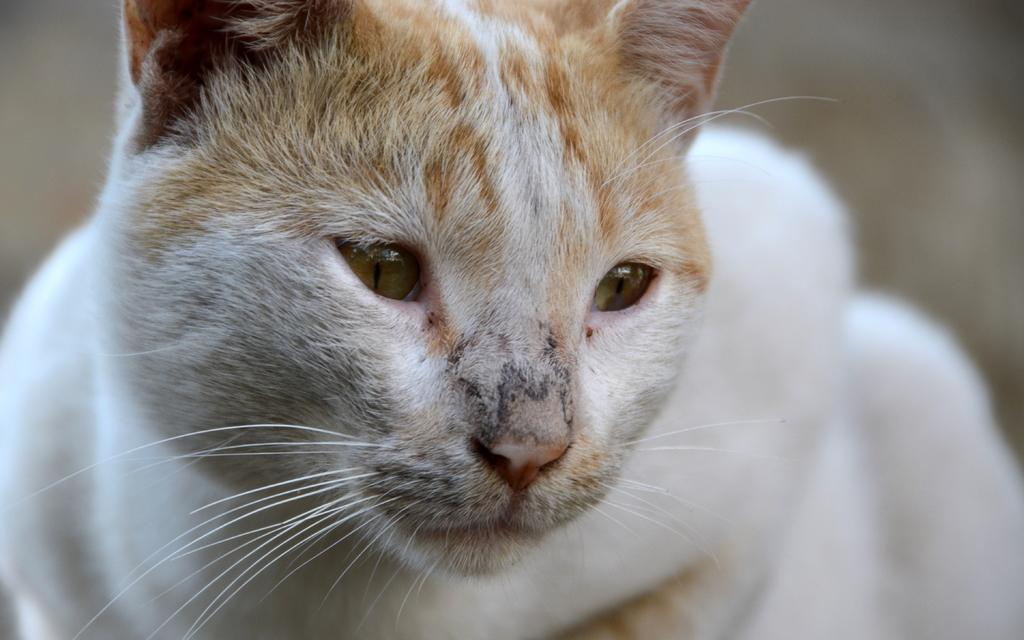What type of animal is in the image? There is a cat in the image. Can you describe the background of the image? The background of the image is blurry. What is the temper of the woman in the image? There is no woman present in the image, only a cat. What type of stone can be seen in the image? There is no stone present in the image. 